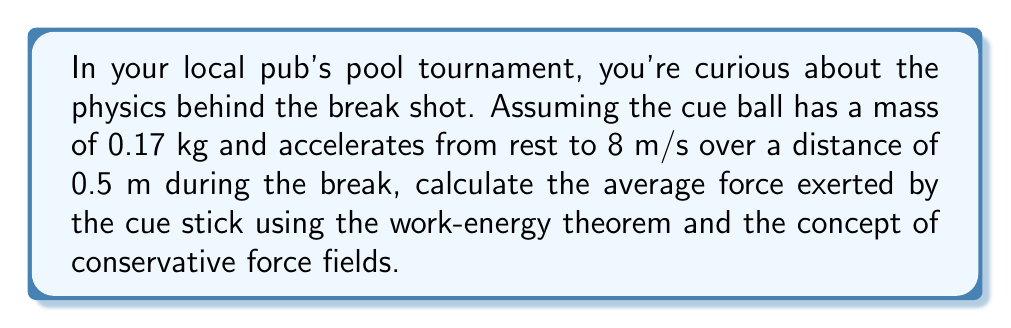What is the answer to this math problem? Let's approach this step-by-step using field theory concepts:

1) The work-energy theorem states that the work done on an object is equal to its change in kinetic energy:

   $$W = \Delta K$$

2) For a conservative force field, work is independent of the path and can be expressed as the negative gradient of a potential energy function. In this case, we can use the concept of a uniform force field, where:

   $$\vec{F} = -\nabla U$$

   And the work done is:

   $$W = -\Delta U = F \cdot d$$

3) The change in kinetic energy is:

   $$\Delta K = \frac{1}{2}mv_f^2 - \frac{1}{2}mv_i^2$$

4) Given:
   - Mass of cue ball, $m = 0.17$ kg
   - Initial velocity, $v_i = 0$ m/s
   - Final velocity, $v_f = 8$ m/s
   - Distance, $d = 0.5$ m

5) Calculate the change in kinetic energy:

   $$\Delta K = \frac{1}{2}(0.17)(8^2) - \frac{1}{2}(0.17)(0^2) = 5.44 \text{ J}$$

6) Using the work-energy theorem:

   $$W = \Delta K = 5.44 \text{ J}$$

7) For a uniform force field over the given distance:

   $$F \cdot d = 5.44 \text{ J}$$

8) Solve for the force:

   $$F = \frac{5.44 \text{ J}}{0.5 \text{ m}} = 10.88 \text{ N}$$

Therefore, the average force exerted by the cue stick during the break shot is 10.88 N.
Answer: 10.88 N 